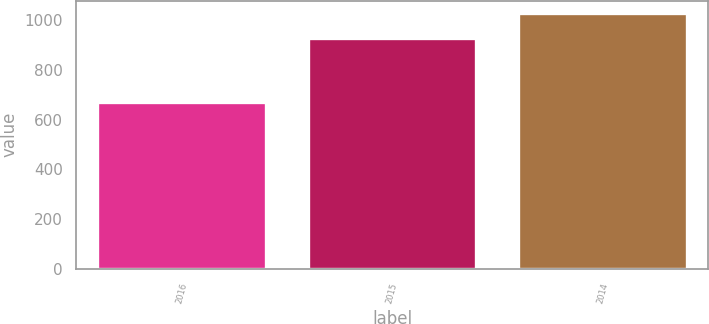Convert chart to OTSL. <chart><loc_0><loc_0><loc_500><loc_500><bar_chart><fcel>2016<fcel>2015<fcel>2014<nl><fcel>670.8<fcel>929.4<fcel>1027.6<nl></chart> 